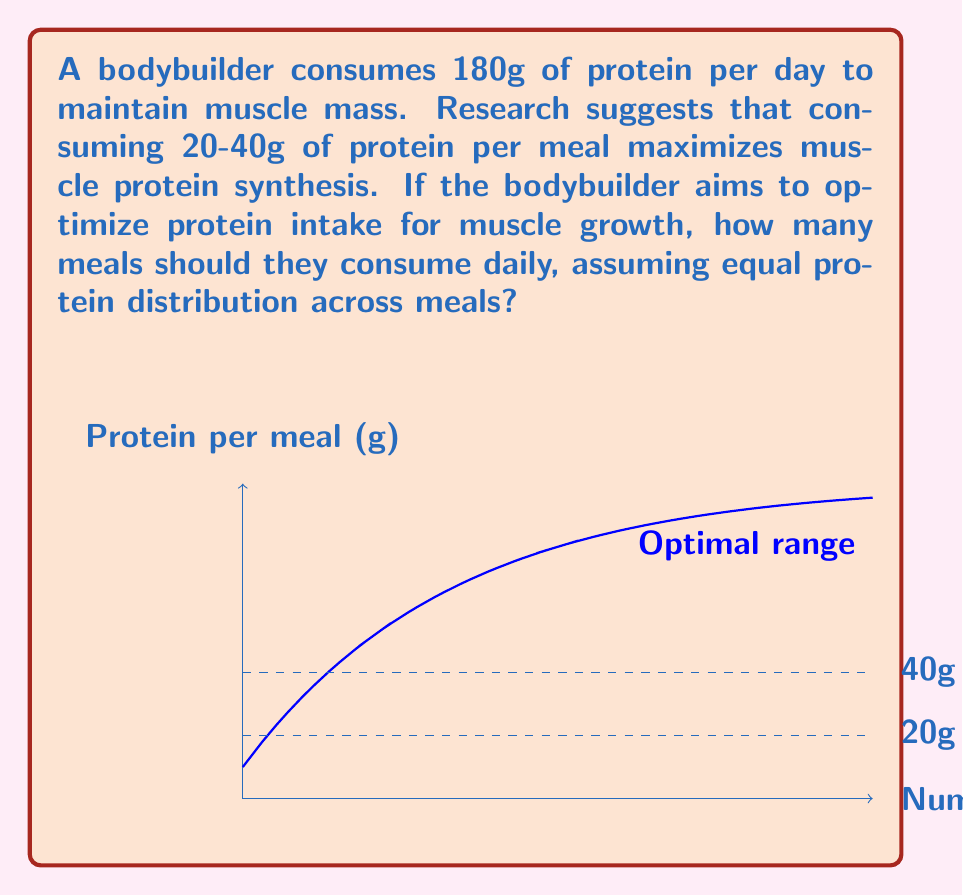Show me your answer to this math problem. Let's approach this step-by-step:

1) The bodybuilder consumes a total of 180g of protein per day.

2) The optimal range for protein per meal is 20-40g.

3) To find the number of meals, we need to divide the total protein by the protein per meal:

   $$\text{Number of meals} = \frac{\text{Total protein}}{\text{Protein per meal}}$$

4) Let's calculate for both extremes of the optimal range:

   For 20g per meal: $$\text{Number of meals} = \frac{180g}{20g} = 9\text{ meals}$$
   For 40g per meal: $$\text{Number of meals} = \frac{180g}{40g} = 4.5\text{ meals}$$

5) Since we can't have fractional meals, we round down to 4 meals for the 40g case.

6) Therefore, the optimal range for the number of meals is between 4 and 9.

7) To maximize muscle protein synthesis while minimizing the number of meals (for practicality), we should choose the lower end of this range.

8) Checking our work: 
   $$\frac{180g}{4\text{ meals}} = 45g\text{ per meal}$$
   This is slightly above the optimal range but still close enough to be effective.
Answer: 4 meals 